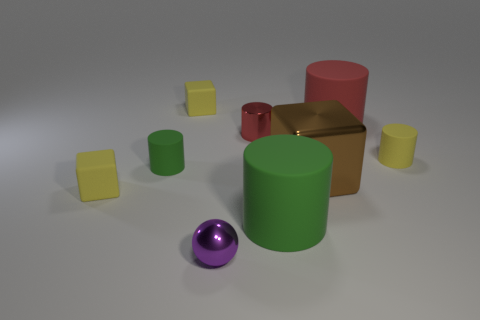There is a thing that is the same color as the metal cylinder; what is its size?
Offer a very short reply. Large. Are there fewer tiny gray shiny balls than small green matte cylinders?
Give a very brief answer. Yes. The red cylinder that is the same material as the brown thing is what size?
Offer a terse response. Small. How big is the metallic cylinder?
Ensure brevity in your answer.  Small. What shape is the brown metallic thing?
Your answer should be very brief. Cube. Is the color of the big rubber thing in front of the large brown shiny thing the same as the tiny metal cylinder?
Your response must be concise. No. What is the size of the red matte thing that is the same shape as the small red shiny object?
Your answer should be very brief. Large. Is there anything else that has the same material as the tiny green object?
Make the answer very short. Yes. There is a small metallic thing in front of the tiny yellow cube in front of the yellow rubber cylinder; are there any big cubes in front of it?
Provide a succinct answer. No. What is the material of the red cylinder to the right of the large shiny cube?
Give a very brief answer. Rubber. 